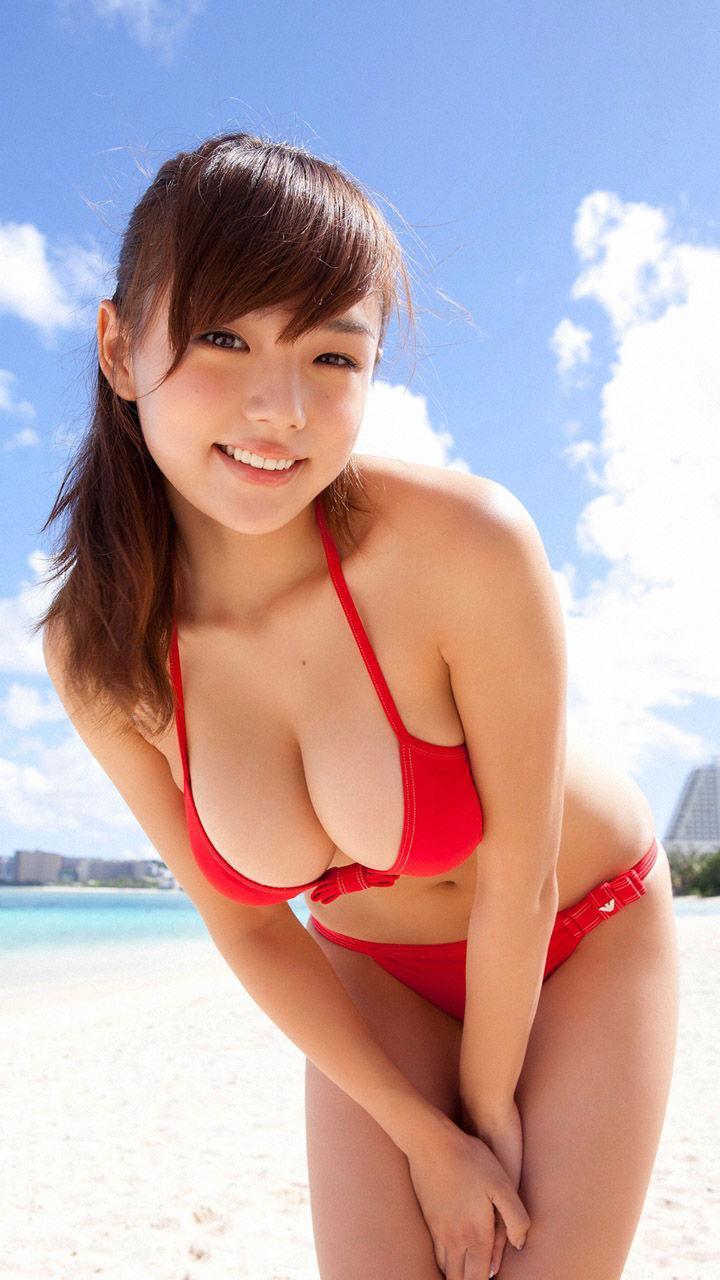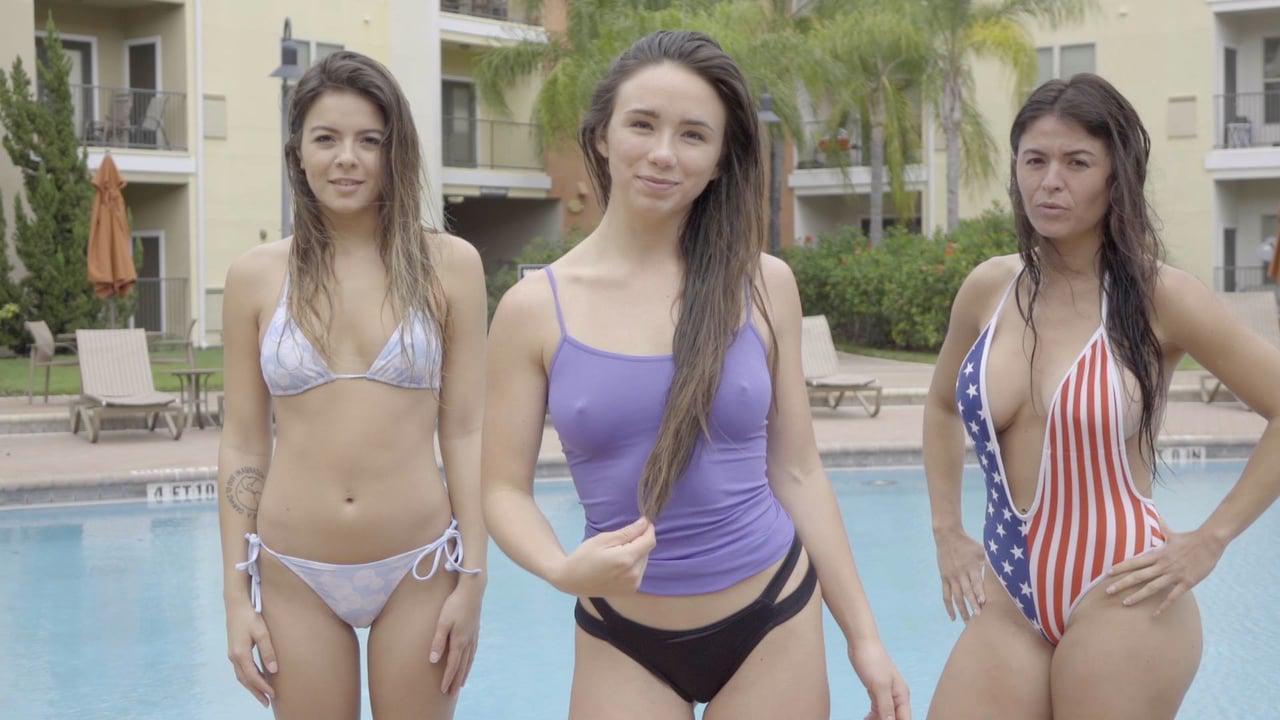The first image is the image on the left, the second image is the image on the right. Examine the images to the left and right. Is the description "There are no more than three women." accurate? Answer yes or no. No. The first image is the image on the left, the second image is the image on the right. For the images displayed, is the sentence "Three camera-facing swimwear models stand side-by-side in front of a swimming pool." factually correct? Answer yes or no. Yes. 